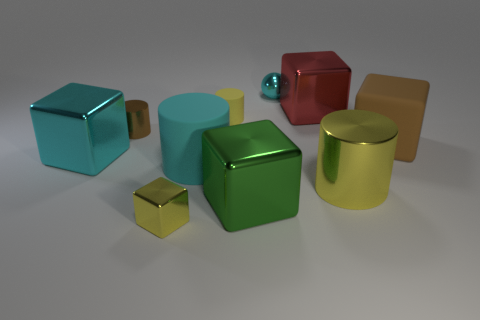What material is the yellow cylinder in front of the large metal thing that is on the left side of the big green thing?
Your answer should be compact. Metal. Are there an equal number of big red objects that are in front of the big rubber cylinder and objects in front of the yellow rubber object?
Ensure brevity in your answer.  No. What number of objects are either tiny brown cylinders behind the brown matte cube or cylinders behind the big cyan cylinder?
Offer a terse response. 2. There is a big cube that is on the left side of the big red shiny cube and on the right side of the tiny shiny cylinder; what is its material?
Provide a short and direct response. Metal. There is a cyan object behind the big cyan object to the left of the small yellow thing in front of the big cyan matte object; what size is it?
Your answer should be very brief. Small. Are there more big brown objects than yellow metal things?
Ensure brevity in your answer.  No. Is the red object in front of the sphere made of the same material as the big green cube?
Ensure brevity in your answer.  Yes. Are there fewer large brown rubber objects than tiny green rubber cylinders?
Give a very brief answer. No. Are there any big cyan metal blocks that are behind the cube that is behind the brown object behind the large rubber block?
Your answer should be compact. No. Is the shape of the brown object right of the big green metallic block the same as  the large yellow shiny object?
Ensure brevity in your answer.  No. 